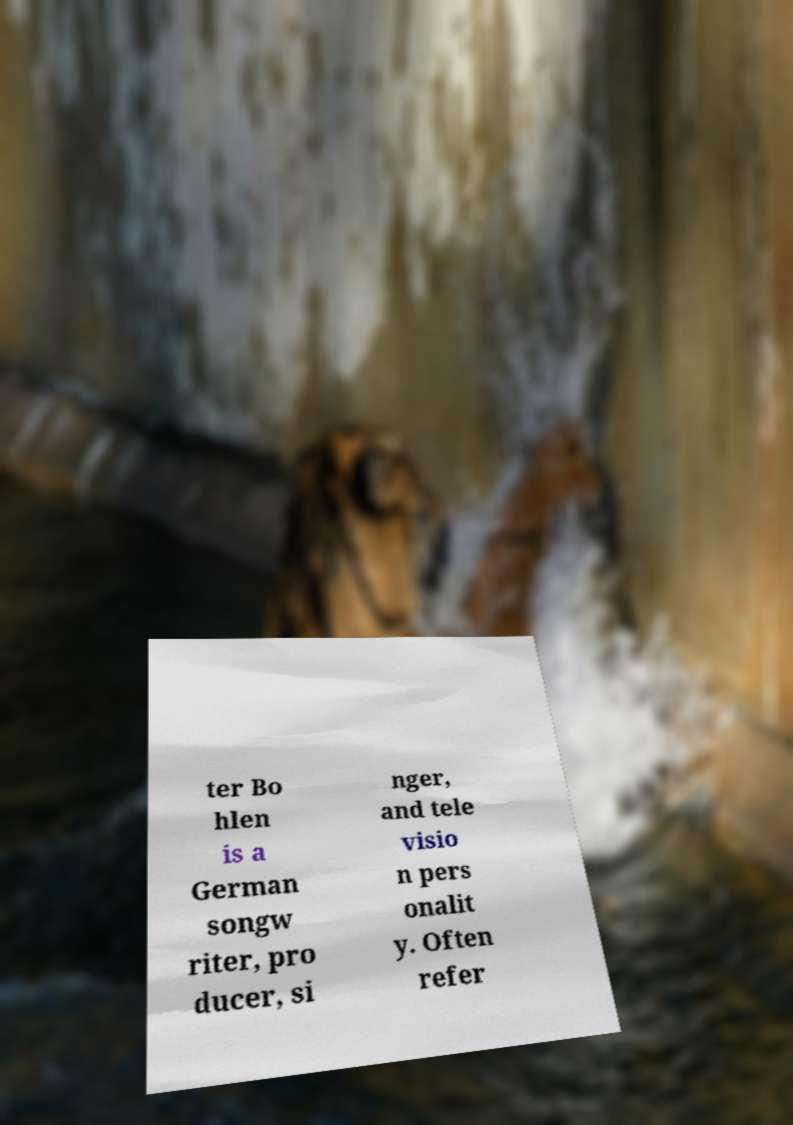Could you assist in decoding the text presented in this image and type it out clearly? ter Bo hlen is a German songw riter, pro ducer, si nger, and tele visio n pers onalit y. Often refer 